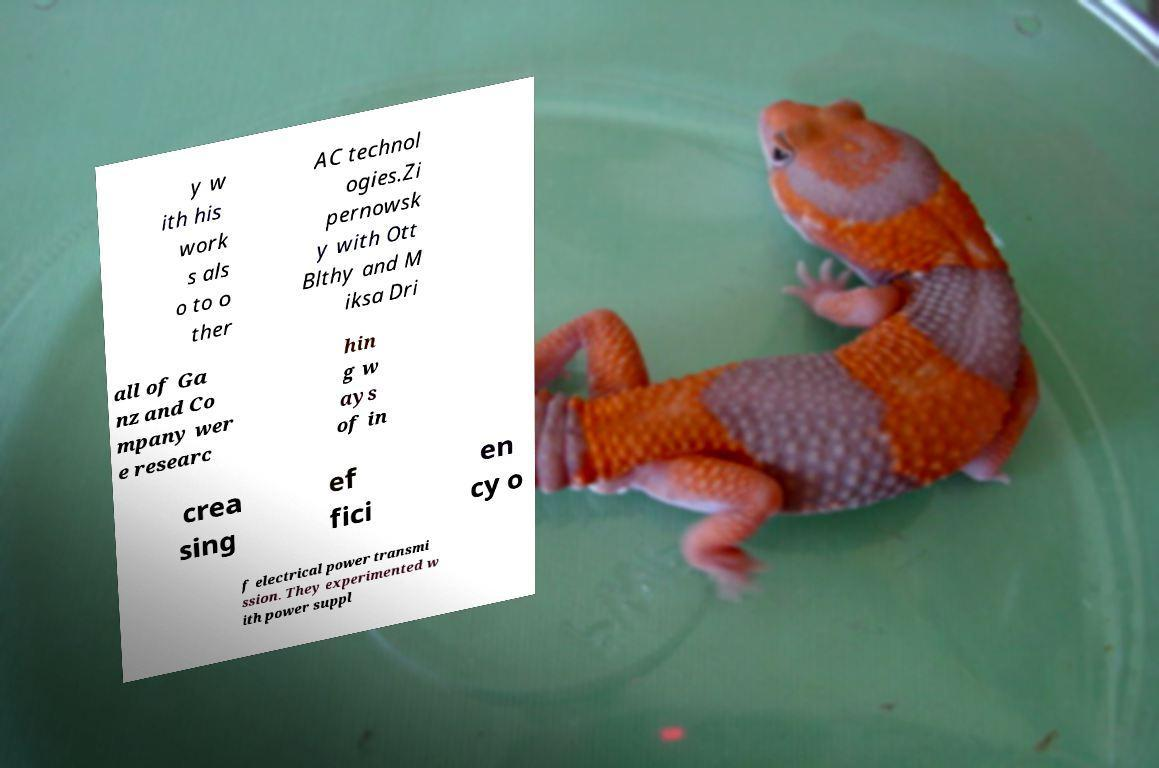Could you extract and type out the text from this image? y w ith his work s als o to o ther AC technol ogies.Zi pernowsk y with Ott Blthy and M iksa Dri all of Ga nz and Co mpany wer e researc hin g w ays of in crea sing ef fici en cy o f electrical power transmi ssion. They experimented w ith power suppl 